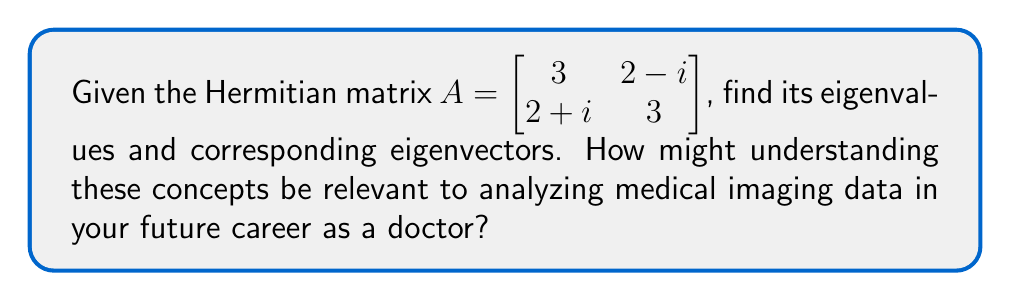Solve this math problem. Let's approach this step-by-step:

1) For a Hermitian matrix, all eigenvalues are real. To find the eigenvalues, we solve the characteristic equation:

   $\det(A - \lambda I) = 0$

2) Expanding this:
   $$\begin{vmatrix} 
   3-\lambda & 2-i \\
   2+i & 3-\lambda
   \end{vmatrix} = 0$$

3) This gives us:
   $(3-\lambda)^2 - (2-i)(2+i) = 0$
   $(3-\lambda)^2 - (4+1) = 0$
   $(3-\lambda)^2 - 5 = 0$

4) Solving this equation:
   $(3-\lambda)^2 = 5$
   $3-\lambda = \pm\sqrt{5}$
   $\lambda = 3 \pm \sqrt{5}$

5) So, the eigenvalues are:
   $\lambda_1 = 3 + \sqrt{5}$ and $\lambda_2 = 3 - \sqrt{5}$

6) For each eigenvalue, we find the corresponding eigenvector $v$ by solving $(A - \lambda I)v = 0$

7) For $\lambda_1 = 3 + \sqrt{5}$:
   $$\begin{bmatrix} 
   -\sqrt{5} & 2-i \\
   2+i & -\sqrt{5}
   \end{bmatrix} \begin{bmatrix} 
   v_1 \\
   v_2
   \end{bmatrix} = \begin{bmatrix} 
   0 \\
   0
   \end{bmatrix}$$

8) This gives us:
   $-\sqrt{5}v_1 + (2-i)v_2 = 0$
   Choose $v_1 = 2-i$ and $v_2 = \sqrt{5}$

9) Similarly, for $\lambda_2 = 3 - \sqrt{5}$, we get:
   $v_1 = 2-i$ and $v_2 = -\sqrt{5}$

10) Normalizing these vectors, we get the eigenvectors:
    $v_1 = \frac{1}{\sqrt{10-2\sqrt{5}}}(2-i, \sqrt{5})^T$
    $v_2 = \frac{1}{\sqrt{10+2\sqrt{5}}}(2-i, -\sqrt{5})^T$

Understanding eigenvalues and eigenvectors is crucial in medical imaging, particularly in techniques like MRI and CT scans. These concepts are used in image processing algorithms to enhance contrast, reduce noise, and compress data, leading to clearer and more informative medical images for diagnosis.
Answer: Eigenvalues: $\lambda_1 = 3 + \sqrt{5}$, $\lambda_2 = 3 - \sqrt{5}$
Eigenvectors: $v_1 = \frac{1}{\sqrt{10-2\sqrt{5}}}(2-i, \sqrt{5})^T$, $v_2 = \frac{1}{\sqrt{10+2\sqrt{5}}}(2-i, -\sqrt{5})^T$ 